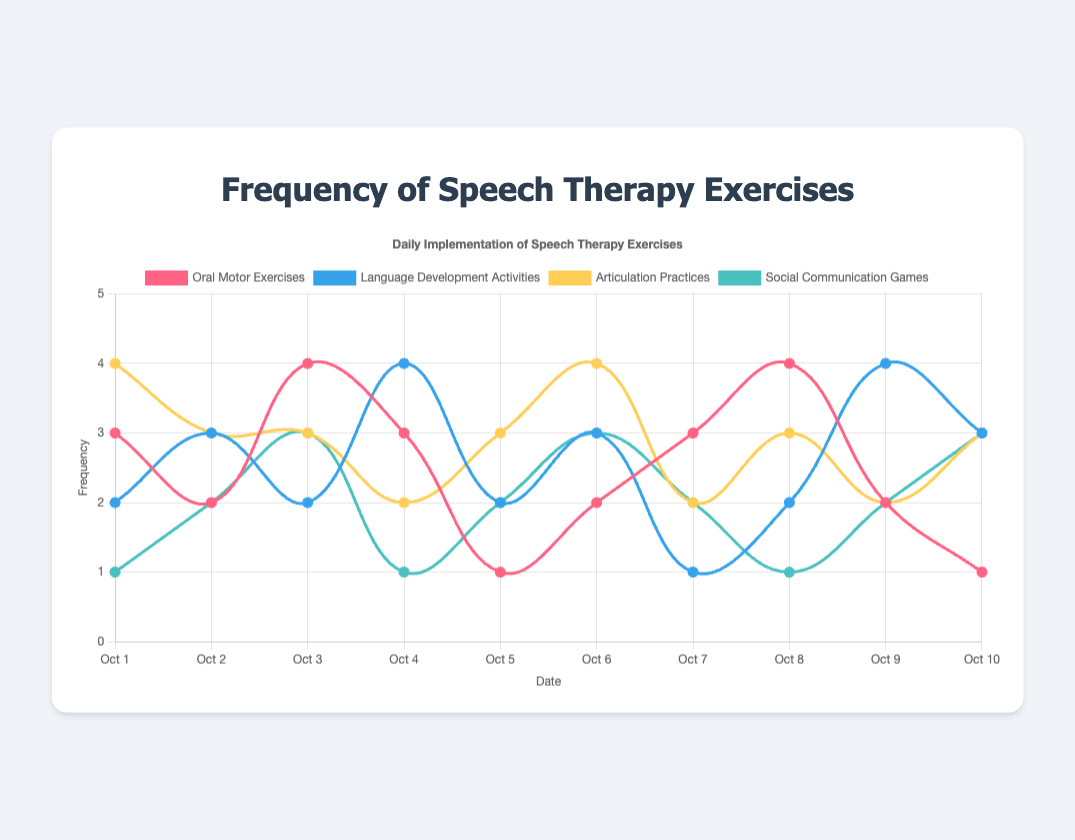What's the highest frequency of Oral Motor Exercises observed? To determine the highest frequency, look for the maximum value in the Oral Motor Exercises line. The highest point on the red line corresponds to 4 exercises.
Answer: 4 On which date was the lowest number of Social Communication Games recorded? Identify the lowest value on the teal line. The lowest point is 1, which appears on Oct 1, Oct 4, and Oct 8.
Answer: Oct 1, Oct 4, Oct 8 What is the average frequency of Language Development Activities over the 10 days? Sum the frequencies of Language Development Activities over the 10 days and divide by 10. (2+3+2+4+2+3+1+2+4+3) = 26, and 26/10 = 2.6
Answer: 2.6 Did Articulation Practices frequency ever equal Social Communication Games frequency on Oct 7? Check the values on Oct 7 for both activities. Articulation Practices have a value of 2, and Social Communication Games also have a value of 2. Therefore, they are equal.
Answer: Yes What is the difference in the number of Oral Motor Exercises between Oct 1 and Oct 10? The frequency for Oct 1 is 3 and for Oct 10 is 1. The difference is 3 - 1 = 2.
Answer: 2 Which exercise had the most consistent frequency over the 10 days? Observe which line exhibits the least fluctuation. The Articulation Practices line (yellow) fluctuates minimally between 2 and 4.
Answer: Articulation Practices Which exercise shows a sudden increase in frequency from Oct 1 to Oct 2? Compare the lines between Oct 1 and Oct 2. Both Social Communication Games (teal) and Language Development Activities (blue) show increases, but the increase for Social Communication Games is from 1 to 2, while the increase for Language Development Activities is from 2 to 3.
Answer: Both, but Social Communication Games has a smaller increment What is the sum of frequencies for Oral Motor Exercises and Social Communication Games on Oct 6? Sum the values for Oct 6. Oral Motor Exercises: 2, Social Communication Games: 3. The sum is 2 + 3 = 5.
Answer: 5 Compare the frequency of Oral Motor Exercises and Language Development activities on Oct 4. Which one is higher? Look at Oct 4 values; Oral Motor Exercises have 3, and Language Development Activities have 4. So, Language Development Activities are higher.
Answer: Language Development Activities 